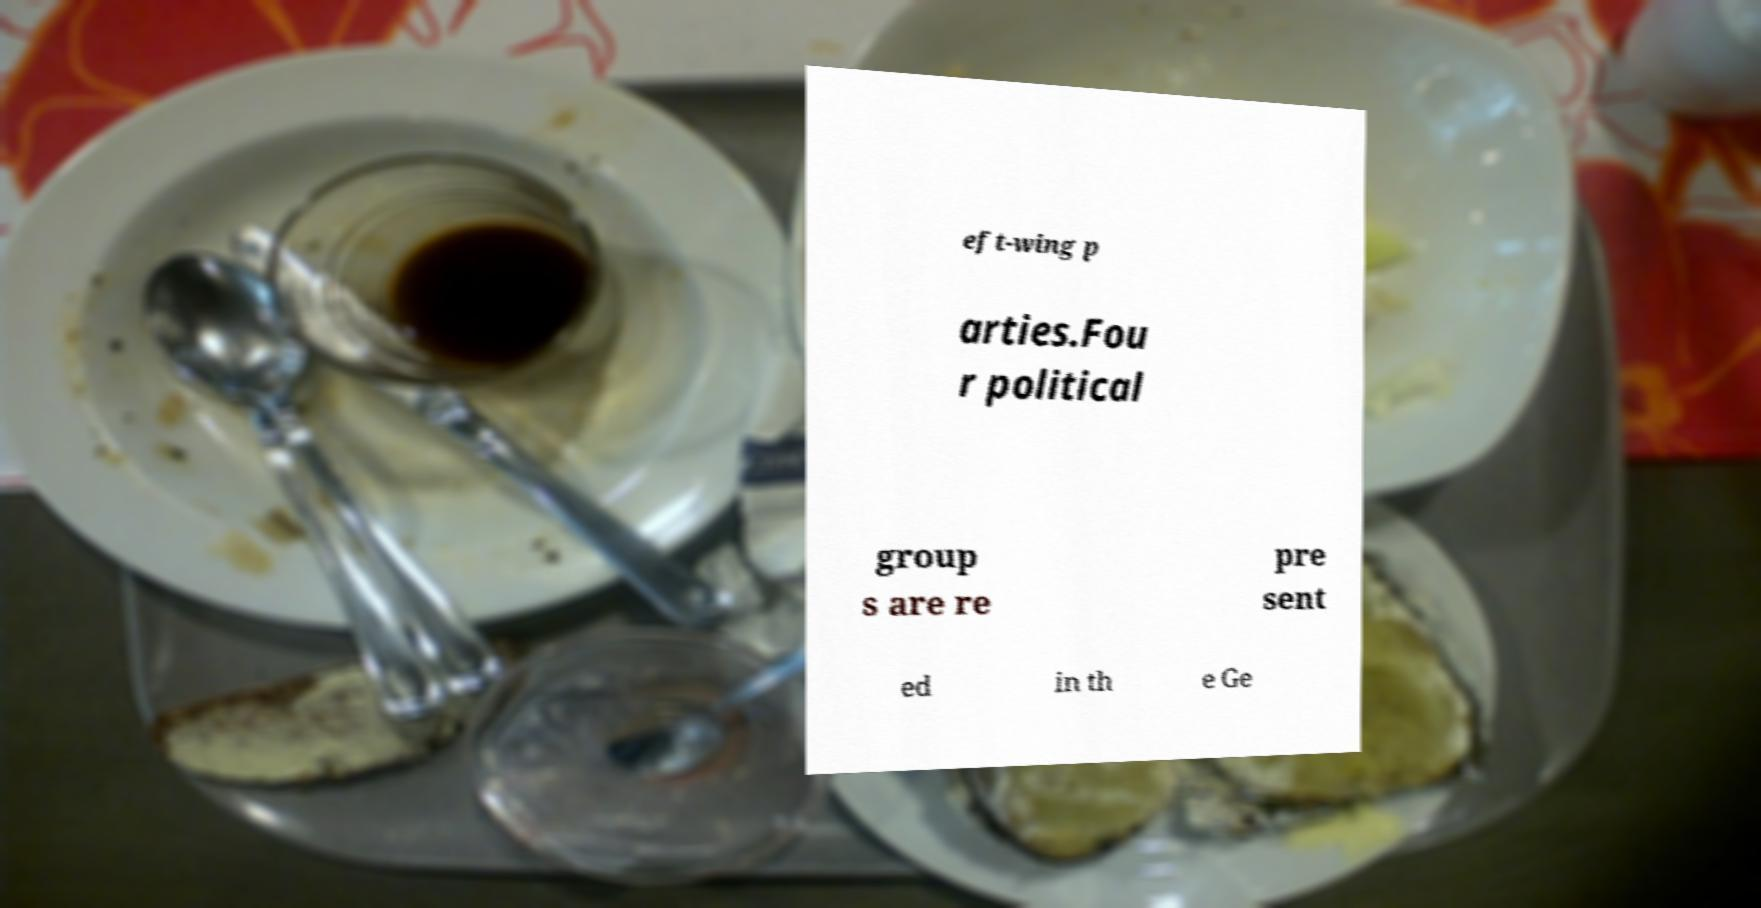There's text embedded in this image that I need extracted. Can you transcribe it verbatim? eft-wing p arties.Fou r political group s are re pre sent ed in th e Ge 